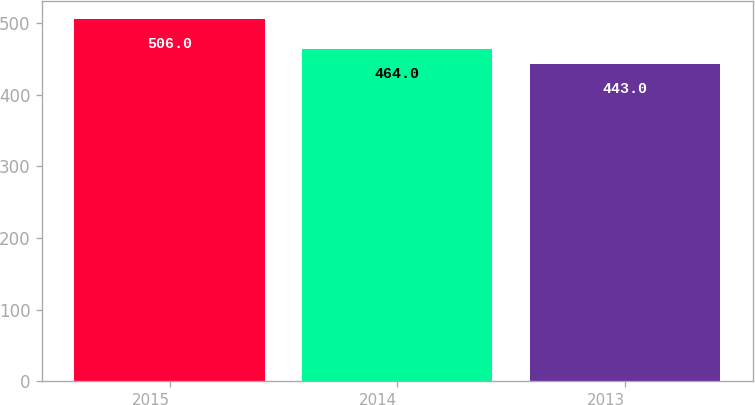<chart> <loc_0><loc_0><loc_500><loc_500><bar_chart><fcel>2015<fcel>2014<fcel>2013<nl><fcel>506<fcel>464<fcel>443<nl></chart> 